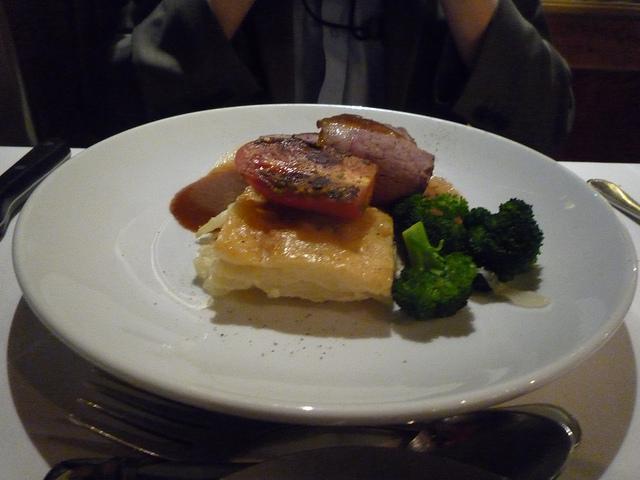Evaluate: Does the caption "The person is touching the broccoli." match the image?
Answer yes or no. No. 